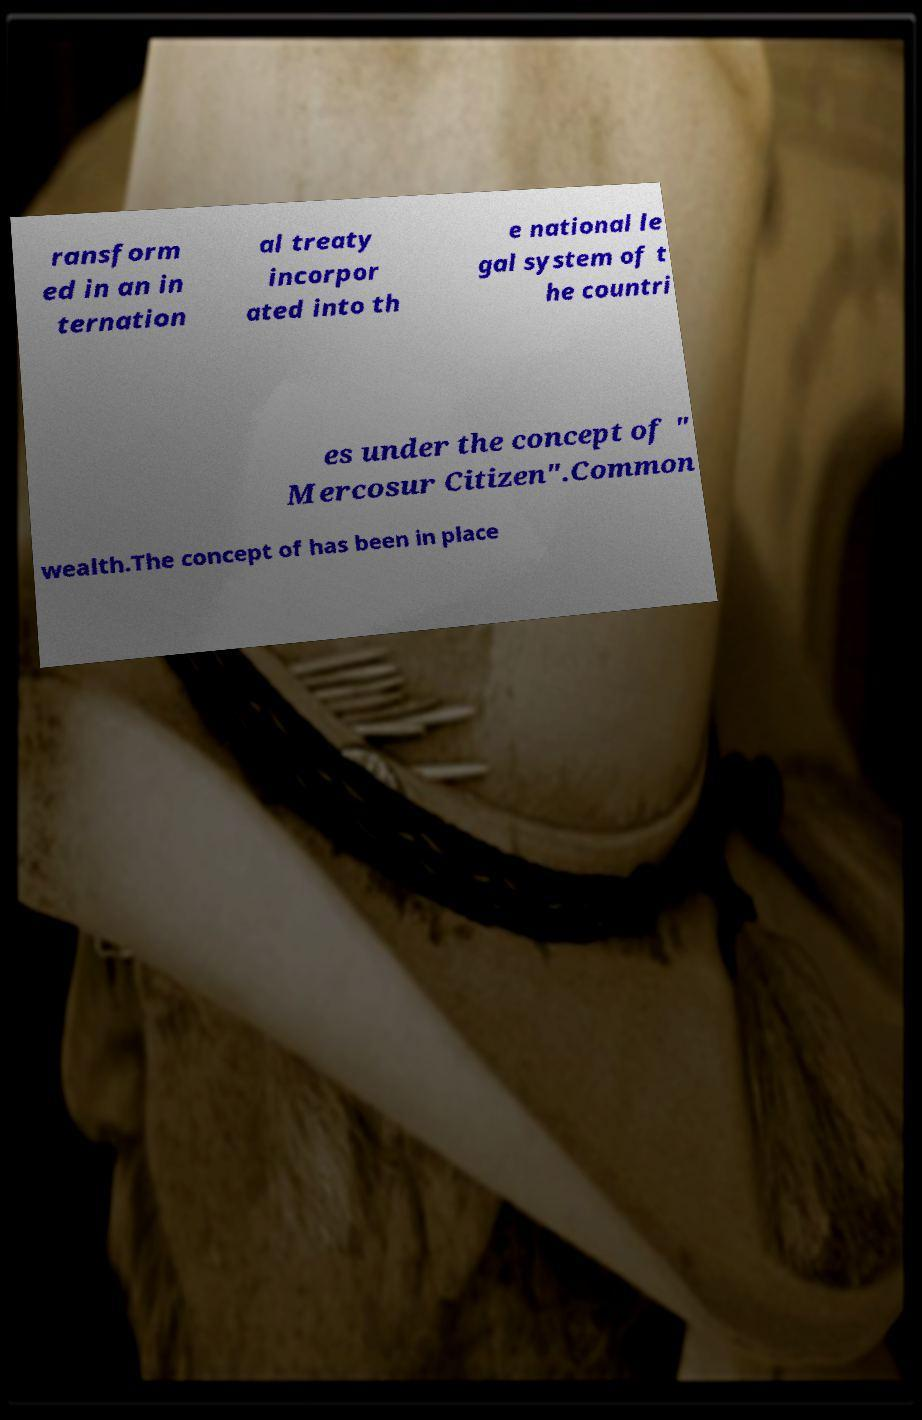There's text embedded in this image that I need extracted. Can you transcribe it verbatim? ransform ed in an in ternation al treaty incorpor ated into th e national le gal system of t he countri es under the concept of " Mercosur Citizen".Common wealth.The concept of has been in place 